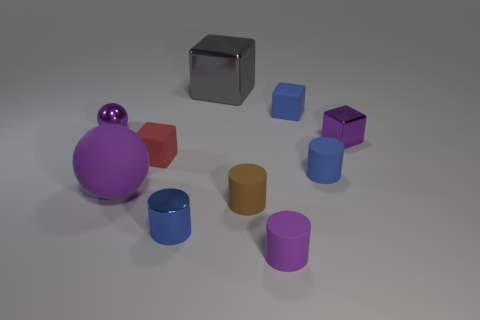There is a sphere that is the same material as the big gray cube; what is its size?
Ensure brevity in your answer.  Small. What number of objects are tiny purple metal objects that are to the right of the large gray shiny thing or tiny cylinders on the left side of the small brown object?
Offer a terse response. 2. There is a metal object right of the blue rubber block; is its size the same as the tiny red block?
Your response must be concise. Yes. The small metal thing that is on the right side of the brown matte object is what color?
Your answer should be compact. Purple. The small thing that is the same shape as the big purple object is what color?
Provide a succinct answer. Purple. How many blue metal cylinders are in front of the tiny metal object that is in front of the matte cylinder to the left of the small purple rubber object?
Offer a terse response. 0. Is there anything else that has the same material as the big purple thing?
Your answer should be very brief. Yes. Is the number of rubber balls behind the tiny sphere less than the number of small things?
Offer a terse response. Yes. Do the big matte thing and the tiny metal cylinder have the same color?
Provide a short and direct response. No. There is another matte thing that is the same shape as the red object; what size is it?
Your answer should be very brief. Small. 